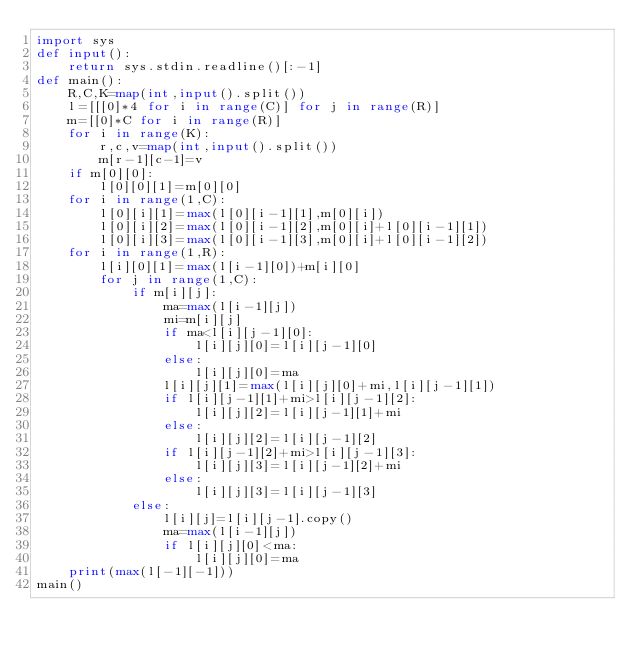Convert code to text. <code><loc_0><loc_0><loc_500><loc_500><_Python_>import sys
def input():
    return sys.stdin.readline()[:-1]
def main():
    R,C,K=map(int,input().split())
    l=[[[0]*4 for i in range(C)] for j in range(R)]
    m=[[0]*C for i in range(R)]
    for i in range(K):
        r,c,v=map(int,input().split())
        m[r-1][c-1]=v
    if m[0][0]:
        l[0][0][1]=m[0][0]
    for i in range(1,C):
        l[0][i][1]=max(l[0][i-1][1],m[0][i])
        l[0][i][2]=max(l[0][i-1][2],m[0][i]+l[0][i-1][1])
        l[0][i][3]=max(l[0][i-1][3],m[0][i]+l[0][i-1][2])
    for i in range(1,R):
        l[i][0][1]=max(l[i-1][0])+m[i][0]
        for j in range(1,C):
            if m[i][j]:
                ma=max(l[i-1][j])
                mi=m[i][j]
                if ma<l[i][j-1][0]:
                    l[i][j][0]=l[i][j-1][0]
                else:
                    l[i][j][0]=ma
                l[i][j][1]=max(l[i][j][0]+mi,l[i][j-1][1])
                if l[i][j-1][1]+mi>l[i][j-1][2]:
                    l[i][j][2]=l[i][j-1][1]+mi
                else:
                    l[i][j][2]=l[i][j-1][2]
                if l[i][j-1][2]+mi>l[i][j-1][3]:
                    l[i][j][3]=l[i][j-1][2]+mi
                else:
                    l[i][j][3]=l[i][j-1][3]
            else:
                l[i][j]=l[i][j-1].copy()
                ma=max(l[i-1][j])
                if l[i][j][0]<ma:
                    l[i][j][0]=ma
    print(max(l[-1][-1]))
main()</code> 